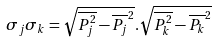Convert formula to latex. <formula><loc_0><loc_0><loc_500><loc_500>\sigma _ { j } \sigma _ { k } = \sqrt { \overline { P ^ { 2 } _ { j } } - \overline { P _ { j } } ^ { 2 } } . \sqrt { \overline { P ^ { 2 } _ { k } } - \overline { P _ { k } } ^ { 2 } }</formula> 